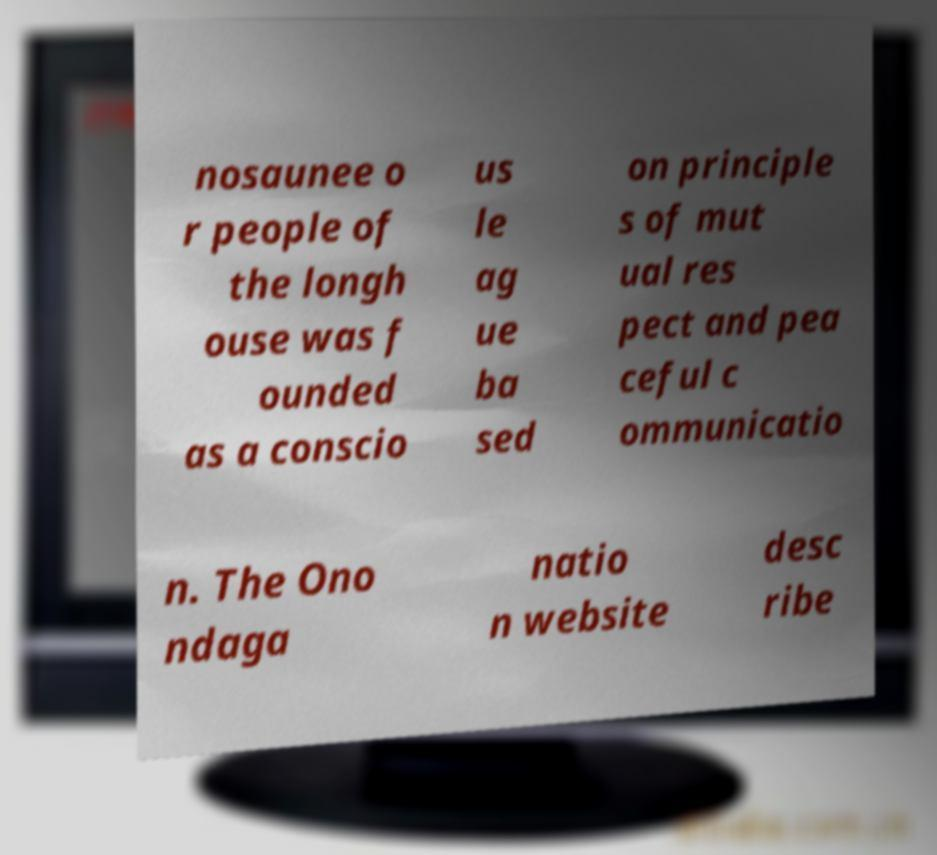For documentation purposes, I need the text within this image transcribed. Could you provide that? nosaunee o r people of the longh ouse was f ounded as a conscio us le ag ue ba sed on principle s of mut ual res pect and pea ceful c ommunicatio n. The Ono ndaga natio n website desc ribe 